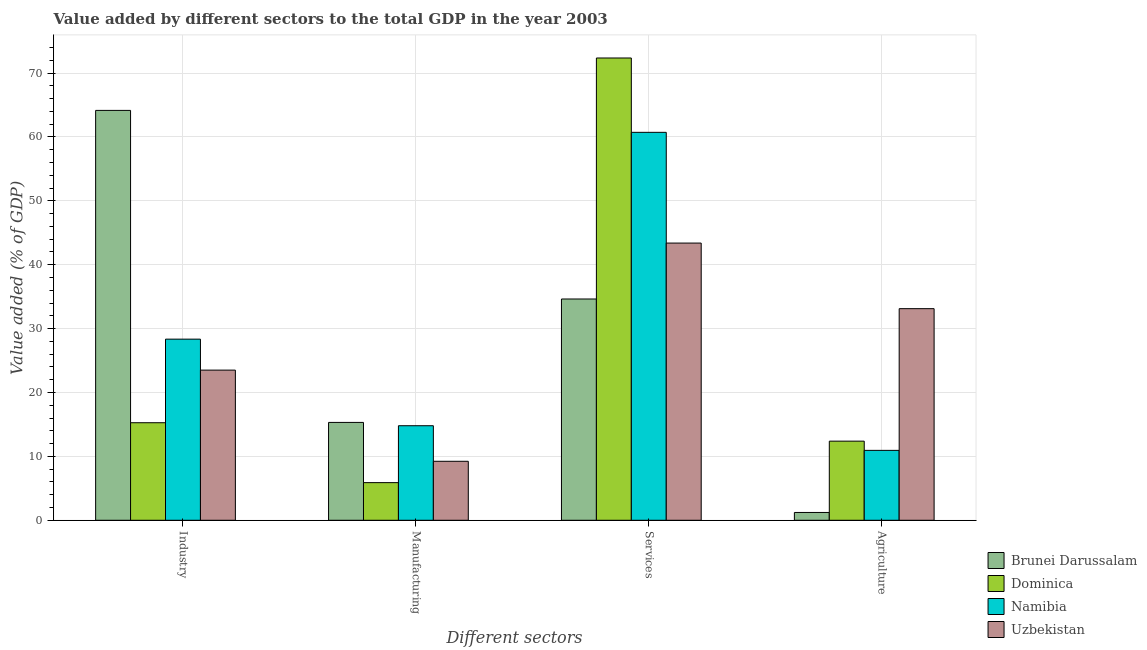How many different coloured bars are there?
Offer a terse response. 4. How many bars are there on the 3rd tick from the left?
Provide a short and direct response. 4. What is the label of the 1st group of bars from the left?
Provide a short and direct response. Industry. What is the value added by agricultural sector in Brunei Darussalam?
Your answer should be very brief. 1.22. Across all countries, what is the maximum value added by agricultural sector?
Your answer should be very brief. 33.12. Across all countries, what is the minimum value added by manufacturing sector?
Offer a very short reply. 5.89. In which country was the value added by industrial sector maximum?
Your answer should be very brief. Brunei Darussalam. In which country was the value added by manufacturing sector minimum?
Your answer should be very brief. Dominica. What is the total value added by services sector in the graph?
Ensure brevity in your answer.  211.08. What is the difference between the value added by manufacturing sector in Dominica and that in Namibia?
Provide a short and direct response. -8.91. What is the difference between the value added by agricultural sector in Brunei Darussalam and the value added by manufacturing sector in Namibia?
Ensure brevity in your answer.  -13.57. What is the average value added by industrial sector per country?
Ensure brevity in your answer.  32.81. What is the difference between the value added by manufacturing sector and value added by industrial sector in Namibia?
Offer a terse response. -13.55. What is the ratio of the value added by manufacturing sector in Brunei Darussalam to that in Dominica?
Offer a terse response. 2.6. Is the value added by manufacturing sector in Brunei Darussalam less than that in Namibia?
Offer a terse response. No. What is the difference between the highest and the second highest value added by agricultural sector?
Offer a very short reply. 20.73. What is the difference between the highest and the lowest value added by manufacturing sector?
Ensure brevity in your answer.  9.43. Is the sum of the value added by industrial sector in Dominica and Namibia greater than the maximum value added by services sector across all countries?
Ensure brevity in your answer.  No. What does the 3rd bar from the left in Industry represents?
Your answer should be very brief. Namibia. What does the 1st bar from the right in Services represents?
Offer a terse response. Uzbekistan. How many bars are there?
Provide a succinct answer. 16. How many countries are there in the graph?
Provide a short and direct response. 4. Are the values on the major ticks of Y-axis written in scientific E-notation?
Your answer should be very brief. No. Does the graph contain any zero values?
Offer a terse response. No. What is the title of the graph?
Make the answer very short. Value added by different sectors to the total GDP in the year 2003. What is the label or title of the X-axis?
Your answer should be very brief. Different sectors. What is the label or title of the Y-axis?
Your answer should be very brief. Value added (% of GDP). What is the Value added (% of GDP) of Brunei Darussalam in Industry?
Your response must be concise. 64.15. What is the Value added (% of GDP) in Dominica in Industry?
Your answer should be very brief. 15.27. What is the Value added (% of GDP) in Namibia in Industry?
Make the answer very short. 28.35. What is the Value added (% of GDP) of Uzbekistan in Industry?
Make the answer very short. 23.5. What is the Value added (% of GDP) in Brunei Darussalam in Manufacturing?
Make the answer very short. 15.32. What is the Value added (% of GDP) in Dominica in Manufacturing?
Provide a short and direct response. 5.89. What is the Value added (% of GDP) of Namibia in Manufacturing?
Give a very brief answer. 14.8. What is the Value added (% of GDP) in Uzbekistan in Manufacturing?
Ensure brevity in your answer.  9.23. What is the Value added (% of GDP) of Brunei Darussalam in Services?
Your answer should be very brief. 34.63. What is the Value added (% of GDP) in Dominica in Services?
Provide a succinct answer. 72.35. What is the Value added (% of GDP) in Namibia in Services?
Provide a succinct answer. 60.71. What is the Value added (% of GDP) in Uzbekistan in Services?
Give a very brief answer. 43.38. What is the Value added (% of GDP) in Brunei Darussalam in Agriculture?
Offer a terse response. 1.22. What is the Value added (% of GDP) of Dominica in Agriculture?
Your response must be concise. 12.38. What is the Value added (% of GDP) in Namibia in Agriculture?
Your answer should be compact. 10.94. What is the Value added (% of GDP) of Uzbekistan in Agriculture?
Give a very brief answer. 33.12. Across all Different sectors, what is the maximum Value added (% of GDP) of Brunei Darussalam?
Offer a terse response. 64.15. Across all Different sectors, what is the maximum Value added (% of GDP) in Dominica?
Keep it short and to the point. 72.35. Across all Different sectors, what is the maximum Value added (% of GDP) of Namibia?
Provide a succinct answer. 60.71. Across all Different sectors, what is the maximum Value added (% of GDP) in Uzbekistan?
Ensure brevity in your answer.  43.38. Across all Different sectors, what is the minimum Value added (% of GDP) in Brunei Darussalam?
Give a very brief answer. 1.22. Across all Different sectors, what is the minimum Value added (% of GDP) in Dominica?
Your response must be concise. 5.89. Across all Different sectors, what is the minimum Value added (% of GDP) in Namibia?
Make the answer very short. 10.94. Across all Different sectors, what is the minimum Value added (% of GDP) in Uzbekistan?
Your answer should be compact. 9.23. What is the total Value added (% of GDP) in Brunei Darussalam in the graph?
Keep it short and to the point. 115.32. What is the total Value added (% of GDP) of Dominica in the graph?
Offer a terse response. 105.89. What is the total Value added (% of GDP) in Namibia in the graph?
Your response must be concise. 114.8. What is the total Value added (% of GDP) in Uzbekistan in the graph?
Provide a short and direct response. 109.23. What is the difference between the Value added (% of GDP) of Brunei Darussalam in Industry and that in Manufacturing?
Your answer should be very brief. 48.83. What is the difference between the Value added (% of GDP) of Dominica in Industry and that in Manufacturing?
Make the answer very short. 9.38. What is the difference between the Value added (% of GDP) in Namibia in Industry and that in Manufacturing?
Your answer should be compact. 13.55. What is the difference between the Value added (% of GDP) of Uzbekistan in Industry and that in Manufacturing?
Offer a very short reply. 14.27. What is the difference between the Value added (% of GDP) in Brunei Darussalam in Industry and that in Services?
Your answer should be very brief. 29.52. What is the difference between the Value added (% of GDP) of Dominica in Industry and that in Services?
Your response must be concise. -57.08. What is the difference between the Value added (% of GDP) of Namibia in Industry and that in Services?
Make the answer very short. -32.37. What is the difference between the Value added (% of GDP) in Uzbekistan in Industry and that in Services?
Keep it short and to the point. -19.88. What is the difference between the Value added (% of GDP) of Brunei Darussalam in Industry and that in Agriculture?
Your answer should be compact. 62.93. What is the difference between the Value added (% of GDP) in Dominica in Industry and that in Agriculture?
Make the answer very short. 2.88. What is the difference between the Value added (% of GDP) of Namibia in Industry and that in Agriculture?
Ensure brevity in your answer.  17.41. What is the difference between the Value added (% of GDP) of Uzbekistan in Industry and that in Agriculture?
Ensure brevity in your answer.  -9.62. What is the difference between the Value added (% of GDP) in Brunei Darussalam in Manufacturing and that in Services?
Provide a short and direct response. -19.31. What is the difference between the Value added (% of GDP) of Dominica in Manufacturing and that in Services?
Your answer should be very brief. -66.46. What is the difference between the Value added (% of GDP) in Namibia in Manufacturing and that in Services?
Make the answer very short. -45.92. What is the difference between the Value added (% of GDP) in Uzbekistan in Manufacturing and that in Services?
Make the answer very short. -34.15. What is the difference between the Value added (% of GDP) of Brunei Darussalam in Manufacturing and that in Agriculture?
Provide a short and direct response. 14.09. What is the difference between the Value added (% of GDP) in Dominica in Manufacturing and that in Agriculture?
Offer a very short reply. -6.49. What is the difference between the Value added (% of GDP) in Namibia in Manufacturing and that in Agriculture?
Your answer should be compact. 3.86. What is the difference between the Value added (% of GDP) in Uzbekistan in Manufacturing and that in Agriculture?
Keep it short and to the point. -23.89. What is the difference between the Value added (% of GDP) of Brunei Darussalam in Services and that in Agriculture?
Your answer should be very brief. 33.41. What is the difference between the Value added (% of GDP) of Dominica in Services and that in Agriculture?
Ensure brevity in your answer.  59.97. What is the difference between the Value added (% of GDP) in Namibia in Services and that in Agriculture?
Your answer should be compact. 49.77. What is the difference between the Value added (% of GDP) of Uzbekistan in Services and that in Agriculture?
Offer a very short reply. 10.27. What is the difference between the Value added (% of GDP) of Brunei Darussalam in Industry and the Value added (% of GDP) of Dominica in Manufacturing?
Keep it short and to the point. 58.26. What is the difference between the Value added (% of GDP) of Brunei Darussalam in Industry and the Value added (% of GDP) of Namibia in Manufacturing?
Make the answer very short. 49.35. What is the difference between the Value added (% of GDP) of Brunei Darussalam in Industry and the Value added (% of GDP) of Uzbekistan in Manufacturing?
Make the answer very short. 54.92. What is the difference between the Value added (% of GDP) of Dominica in Industry and the Value added (% of GDP) of Namibia in Manufacturing?
Provide a succinct answer. 0.47. What is the difference between the Value added (% of GDP) of Dominica in Industry and the Value added (% of GDP) of Uzbekistan in Manufacturing?
Provide a short and direct response. 6.04. What is the difference between the Value added (% of GDP) in Namibia in Industry and the Value added (% of GDP) in Uzbekistan in Manufacturing?
Your response must be concise. 19.12. What is the difference between the Value added (% of GDP) in Brunei Darussalam in Industry and the Value added (% of GDP) in Dominica in Services?
Give a very brief answer. -8.2. What is the difference between the Value added (% of GDP) in Brunei Darussalam in Industry and the Value added (% of GDP) in Namibia in Services?
Provide a short and direct response. 3.43. What is the difference between the Value added (% of GDP) in Brunei Darussalam in Industry and the Value added (% of GDP) in Uzbekistan in Services?
Ensure brevity in your answer.  20.76. What is the difference between the Value added (% of GDP) of Dominica in Industry and the Value added (% of GDP) of Namibia in Services?
Give a very brief answer. -45.45. What is the difference between the Value added (% of GDP) of Dominica in Industry and the Value added (% of GDP) of Uzbekistan in Services?
Make the answer very short. -28.12. What is the difference between the Value added (% of GDP) in Namibia in Industry and the Value added (% of GDP) in Uzbekistan in Services?
Your answer should be very brief. -15.04. What is the difference between the Value added (% of GDP) in Brunei Darussalam in Industry and the Value added (% of GDP) in Dominica in Agriculture?
Give a very brief answer. 51.76. What is the difference between the Value added (% of GDP) in Brunei Darussalam in Industry and the Value added (% of GDP) in Namibia in Agriculture?
Make the answer very short. 53.21. What is the difference between the Value added (% of GDP) of Brunei Darussalam in Industry and the Value added (% of GDP) of Uzbekistan in Agriculture?
Offer a very short reply. 31.03. What is the difference between the Value added (% of GDP) in Dominica in Industry and the Value added (% of GDP) in Namibia in Agriculture?
Your answer should be compact. 4.33. What is the difference between the Value added (% of GDP) of Dominica in Industry and the Value added (% of GDP) of Uzbekistan in Agriculture?
Give a very brief answer. -17.85. What is the difference between the Value added (% of GDP) in Namibia in Industry and the Value added (% of GDP) in Uzbekistan in Agriculture?
Offer a very short reply. -4.77. What is the difference between the Value added (% of GDP) of Brunei Darussalam in Manufacturing and the Value added (% of GDP) of Dominica in Services?
Your answer should be compact. -57.03. What is the difference between the Value added (% of GDP) in Brunei Darussalam in Manufacturing and the Value added (% of GDP) in Namibia in Services?
Provide a short and direct response. -45.4. What is the difference between the Value added (% of GDP) in Brunei Darussalam in Manufacturing and the Value added (% of GDP) in Uzbekistan in Services?
Provide a short and direct response. -28.07. What is the difference between the Value added (% of GDP) in Dominica in Manufacturing and the Value added (% of GDP) in Namibia in Services?
Keep it short and to the point. -54.82. What is the difference between the Value added (% of GDP) in Dominica in Manufacturing and the Value added (% of GDP) in Uzbekistan in Services?
Your answer should be very brief. -37.49. What is the difference between the Value added (% of GDP) in Namibia in Manufacturing and the Value added (% of GDP) in Uzbekistan in Services?
Provide a short and direct response. -28.59. What is the difference between the Value added (% of GDP) in Brunei Darussalam in Manufacturing and the Value added (% of GDP) in Dominica in Agriculture?
Provide a short and direct response. 2.93. What is the difference between the Value added (% of GDP) of Brunei Darussalam in Manufacturing and the Value added (% of GDP) of Namibia in Agriculture?
Offer a terse response. 4.38. What is the difference between the Value added (% of GDP) in Brunei Darussalam in Manufacturing and the Value added (% of GDP) in Uzbekistan in Agriculture?
Give a very brief answer. -17.8. What is the difference between the Value added (% of GDP) of Dominica in Manufacturing and the Value added (% of GDP) of Namibia in Agriculture?
Offer a very short reply. -5.05. What is the difference between the Value added (% of GDP) in Dominica in Manufacturing and the Value added (% of GDP) in Uzbekistan in Agriculture?
Make the answer very short. -27.23. What is the difference between the Value added (% of GDP) in Namibia in Manufacturing and the Value added (% of GDP) in Uzbekistan in Agriculture?
Ensure brevity in your answer.  -18.32. What is the difference between the Value added (% of GDP) in Brunei Darussalam in Services and the Value added (% of GDP) in Dominica in Agriculture?
Offer a very short reply. 22.25. What is the difference between the Value added (% of GDP) of Brunei Darussalam in Services and the Value added (% of GDP) of Namibia in Agriculture?
Your answer should be very brief. 23.69. What is the difference between the Value added (% of GDP) in Brunei Darussalam in Services and the Value added (% of GDP) in Uzbekistan in Agriculture?
Offer a terse response. 1.51. What is the difference between the Value added (% of GDP) in Dominica in Services and the Value added (% of GDP) in Namibia in Agriculture?
Keep it short and to the point. 61.41. What is the difference between the Value added (% of GDP) of Dominica in Services and the Value added (% of GDP) of Uzbekistan in Agriculture?
Your response must be concise. 39.23. What is the difference between the Value added (% of GDP) in Namibia in Services and the Value added (% of GDP) in Uzbekistan in Agriculture?
Make the answer very short. 27.6. What is the average Value added (% of GDP) of Brunei Darussalam per Different sectors?
Offer a terse response. 28.83. What is the average Value added (% of GDP) of Dominica per Different sectors?
Offer a terse response. 26.47. What is the average Value added (% of GDP) of Namibia per Different sectors?
Provide a succinct answer. 28.7. What is the average Value added (% of GDP) of Uzbekistan per Different sectors?
Your answer should be compact. 27.31. What is the difference between the Value added (% of GDP) in Brunei Darussalam and Value added (% of GDP) in Dominica in Industry?
Give a very brief answer. 48.88. What is the difference between the Value added (% of GDP) in Brunei Darussalam and Value added (% of GDP) in Namibia in Industry?
Your response must be concise. 35.8. What is the difference between the Value added (% of GDP) in Brunei Darussalam and Value added (% of GDP) in Uzbekistan in Industry?
Make the answer very short. 40.65. What is the difference between the Value added (% of GDP) of Dominica and Value added (% of GDP) of Namibia in Industry?
Make the answer very short. -13.08. What is the difference between the Value added (% of GDP) in Dominica and Value added (% of GDP) in Uzbekistan in Industry?
Your answer should be very brief. -8.23. What is the difference between the Value added (% of GDP) in Namibia and Value added (% of GDP) in Uzbekistan in Industry?
Your response must be concise. 4.85. What is the difference between the Value added (% of GDP) in Brunei Darussalam and Value added (% of GDP) in Dominica in Manufacturing?
Provide a succinct answer. 9.43. What is the difference between the Value added (% of GDP) of Brunei Darussalam and Value added (% of GDP) of Namibia in Manufacturing?
Make the answer very short. 0.52. What is the difference between the Value added (% of GDP) in Brunei Darussalam and Value added (% of GDP) in Uzbekistan in Manufacturing?
Make the answer very short. 6.08. What is the difference between the Value added (% of GDP) in Dominica and Value added (% of GDP) in Namibia in Manufacturing?
Keep it short and to the point. -8.91. What is the difference between the Value added (% of GDP) in Dominica and Value added (% of GDP) in Uzbekistan in Manufacturing?
Provide a short and direct response. -3.34. What is the difference between the Value added (% of GDP) of Namibia and Value added (% of GDP) of Uzbekistan in Manufacturing?
Your response must be concise. 5.57. What is the difference between the Value added (% of GDP) of Brunei Darussalam and Value added (% of GDP) of Dominica in Services?
Make the answer very short. -37.72. What is the difference between the Value added (% of GDP) of Brunei Darussalam and Value added (% of GDP) of Namibia in Services?
Make the answer very short. -26.08. What is the difference between the Value added (% of GDP) of Brunei Darussalam and Value added (% of GDP) of Uzbekistan in Services?
Give a very brief answer. -8.75. What is the difference between the Value added (% of GDP) of Dominica and Value added (% of GDP) of Namibia in Services?
Your response must be concise. 11.64. What is the difference between the Value added (% of GDP) of Dominica and Value added (% of GDP) of Uzbekistan in Services?
Give a very brief answer. 28.97. What is the difference between the Value added (% of GDP) of Namibia and Value added (% of GDP) of Uzbekistan in Services?
Keep it short and to the point. 17.33. What is the difference between the Value added (% of GDP) in Brunei Darussalam and Value added (% of GDP) in Dominica in Agriculture?
Provide a short and direct response. -11.16. What is the difference between the Value added (% of GDP) in Brunei Darussalam and Value added (% of GDP) in Namibia in Agriculture?
Offer a very short reply. -9.72. What is the difference between the Value added (% of GDP) in Brunei Darussalam and Value added (% of GDP) in Uzbekistan in Agriculture?
Keep it short and to the point. -31.9. What is the difference between the Value added (% of GDP) in Dominica and Value added (% of GDP) in Namibia in Agriculture?
Provide a succinct answer. 1.44. What is the difference between the Value added (% of GDP) in Dominica and Value added (% of GDP) in Uzbekistan in Agriculture?
Your answer should be compact. -20.73. What is the difference between the Value added (% of GDP) of Namibia and Value added (% of GDP) of Uzbekistan in Agriculture?
Provide a short and direct response. -22.18. What is the ratio of the Value added (% of GDP) in Brunei Darussalam in Industry to that in Manufacturing?
Provide a short and direct response. 4.19. What is the ratio of the Value added (% of GDP) in Dominica in Industry to that in Manufacturing?
Make the answer very short. 2.59. What is the ratio of the Value added (% of GDP) in Namibia in Industry to that in Manufacturing?
Your answer should be very brief. 1.92. What is the ratio of the Value added (% of GDP) of Uzbekistan in Industry to that in Manufacturing?
Your answer should be compact. 2.55. What is the ratio of the Value added (% of GDP) of Brunei Darussalam in Industry to that in Services?
Your response must be concise. 1.85. What is the ratio of the Value added (% of GDP) of Dominica in Industry to that in Services?
Make the answer very short. 0.21. What is the ratio of the Value added (% of GDP) of Namibia in Industry to that in Services?
Your answer should be very brief. 0.47. What is the ratio of the Value added (% of GDP) of Uzbekistan in Industry to that in Services?
Ensure brevity in your answer.  0.54. What is the ratio of the Value added (% of GDP) of Brunei Darussalam in Industry to that in Agriculture?
Make the answer very short. 52.49. What is the ratio of the Value added (% of GDP) in Dominica in Industry to that in Agriculture?
Ensure brevity in your answer.  1.23. What is the ratio of the Value added (% of GDP) in Namibia in Industry to that in Agriculture?
Keep it short and to the point. 2.59. What is the ratio of the Value added (% of GDP) of Uzbekistan in Industry to that in Agriculture?
Ensure brevity in your answer.  0.71. What is the ratio of the Value added (% of GDP) in Brunei Darussalam in Manufacturing to that in Services?
Give a very brief answer. 0.44. What is the ratio of the Value added (% of GDP) of Dominica in Manufacturing to that in Services?
Ensure brevity in your answer.  0.08. What is the ratio of the Value added (% of GDP) in Namibia in Manufacturing to that in Services?
Provide a succinct answer. 0.24. What is the ratio of the Value added (% of GDP) of Uzbekistan in Manufacturing to that in Services?
Offer a terse response. 0.21. What is the ratio of the Value added (% of GDP) in Brunei Darussalam in Manufacturing to that in Agriculture?
Provide a short and direct response. 12.53. What is the ratio of the Value added (% of GDP) of Dominica in Manufacturing to that in Agriculture?
Keep it short and to the point. 0.48. What is the ratio of the Value added (% of GDP) in Namibia in Manufacturing to that in Agriculture?
Make the answer very short. 1.35. What is the ratio of the Value added (% of GDP) in Uzbekistan in Manufacturing to that in Agriculture?
Your response must be concise. 0.28. What is the ratio of the Value added (% of GDP) in Brunei Darussalam in Services to that in Agriculture?
Offer a terse response. 28.33. What is the ratio of the Value added (% of GDP) in Dominica in Services to that in Agriculture?
Your answer should be compact. 5.84. What is the ratio of the Value added (% of GDP) of Namibia in Services to that in Agriculture?
Your response must be concise. 5.55. What is the ratio of the Value added (% of GDP) of Uzbekistan in Services to that in Agriculture?
Make the answer very short. 1.31. What is the difference between the highest and the second highest Value added (% of GDP) in Brunei Darussalam?
Make the answer very short. 29.52. What is the difference between the highest and the second highest Value added (% of GDP) in Dominica?
Ensure brevity in your answer.  57.08. What is the difference between the highest and the second highest Value added (% of GDP) of Namibia?
Offer a very short reply. 32.37. What is the difference between the highest and the second highest Value added (% of GDP) in Uzbekistan?
Your answer should be compact. 10.27. What is the difference between the highest and the lowest Value added (% of GDP) of Brunei Darussalam?
Provide a short and direct response. 62.93. What is the difference between the highest and the lowest Value added (% of GDP) of Dominica?
Your answer should be compact. 66.46. What is the difference between the highest and the lowest Value added (% of GDP) of Namibia?
Provide a short and direct response. 49.77. What is the difference between the highest and the lowest Value added (% of GDP) in Uzbekistan?
Offer a terse response. 34.15. 